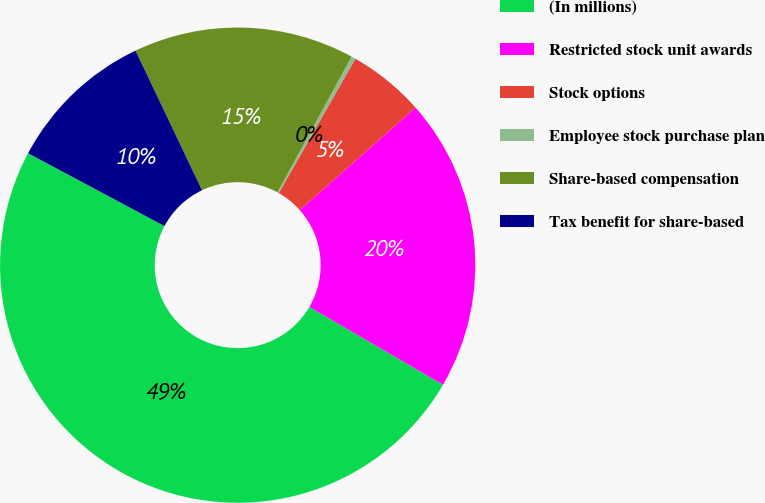<chart> <loc_0><loc_0><loc_500><loc_500><pie_chart><fcel>(In millions)<fcel>Restricted stock unit awards<fcel>Stock options<fcel>Employee stock purchase plan<fcel>Share-based compensation<fcel>Tax benefit for share-based<nl><fcel>49.41%<fcel>19.94%<fcel>5.21%<fcel>0.29%<fcel>15.03%<fcel>10.12%<nl></chart> 